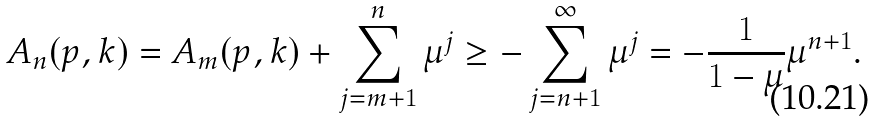<formula> <loc_0><loc_0><loc_500><loc_500>A _ { n } ( p , k ) = A _ { m } ( p , k ) + \sum _ { j = m + 1 } ^ { n } \mu ^ { j } \geq - \sum _ { j = n + 1 } ^ { \infty } \mu ^ { j } = - \frac { 1 } { 1 - \mu } \mu ^ { n + 1 } \text {.}</formula> 